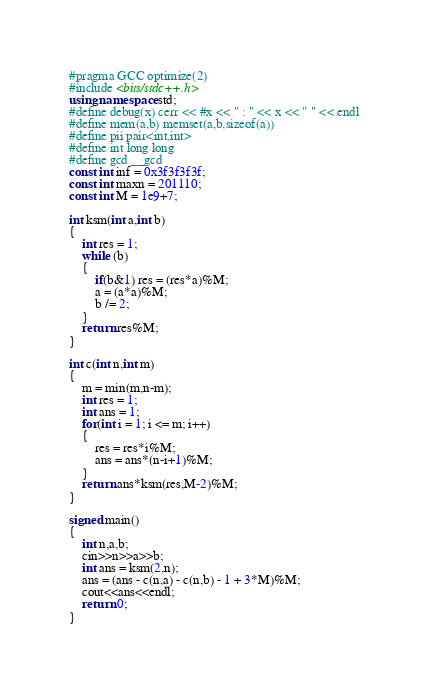<code> <loc_0><loc_0><loc_500><loc_500><_C++_>#pragma GCC optimize(2)
#include <bits/stdc++.h>
using namespace std;
#define debug(x) cerr << #x << " : " << x << " " << endl
#define mem(a,b) memset(a,b,sizeof(a))
#define pii pair<int,int>
#define int long long
#define gcd __gcd
const int inf = 0x3f3f3f3f;
const int maxn = 201110;
const int M = 1e9+7;

int ksm(int a,int b)
{
	int res = 1;
	while (b)
	{
		if(b&1) res = (res*a)%M;
		a = (a*a)%M;
		b /= 2;
	}
	return res%M;
}

int c(int n,int m)
{	
	m = min(m,n-m);
	int res = 1;
	int ans = 1;
	for(int i = 1; i <= m; i++)
	{
		res = res*i%M;
		ans = ans*(n-i+1)%M;
	}
	return ans*ksm(res,M-2)%M;
}

signed main()
{
	int n,a,b;
	cin>>n>>a>>b;
	int ans = ksm(2,n);
	ans = (ans - c(n,a) - c(n,b) - 1 + 3*M)%M;
	cout<<ans<<endl;
	return 0;
}</code> 